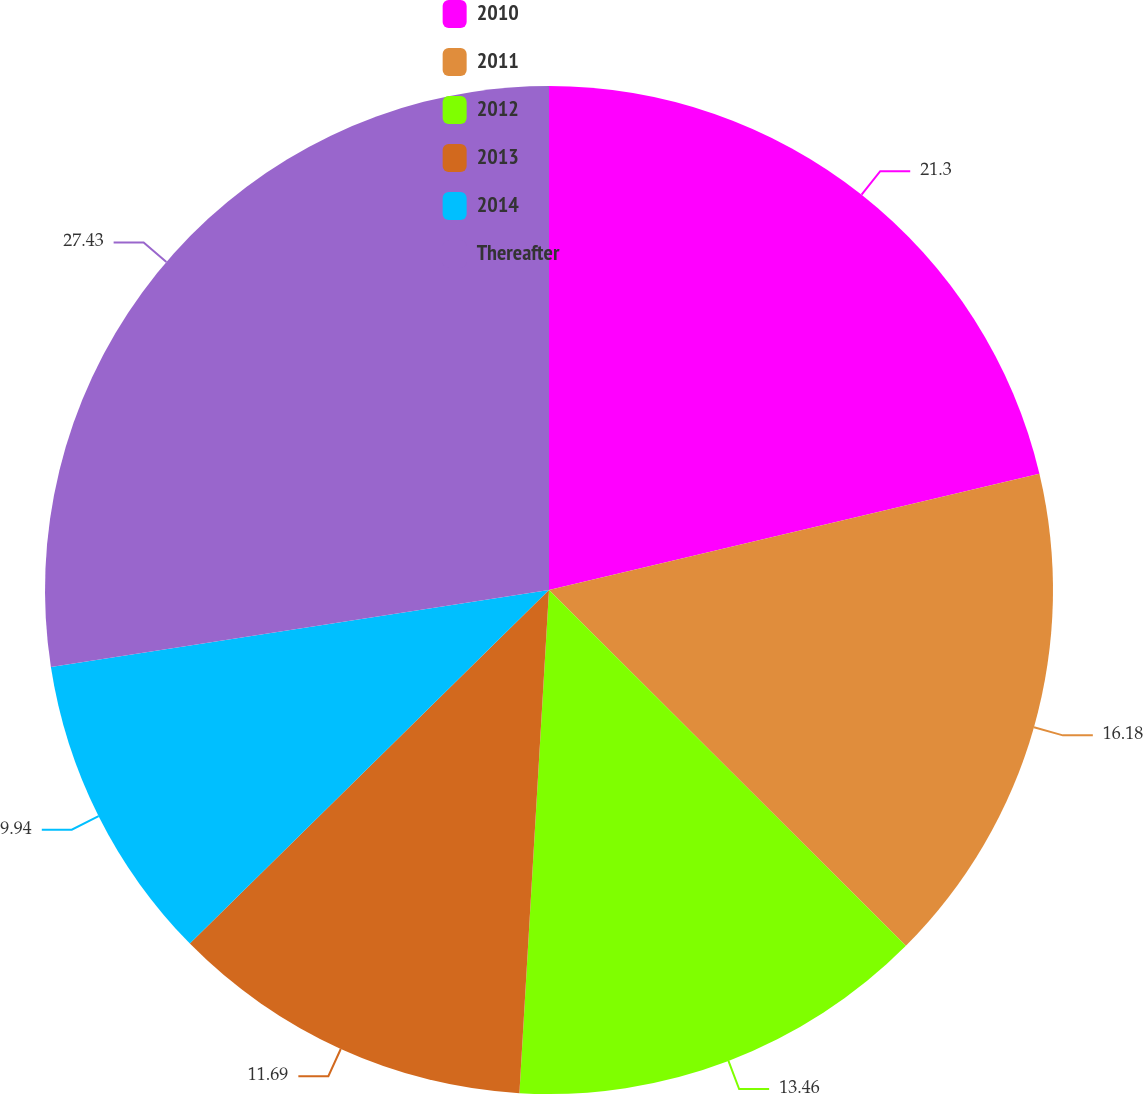Convert chart to OTSL. <chart><loc_0><loc_0><loc_500><loc_500><pie_chart><fcel>2010<fcel>2011<fcel>2012<fcel>2013<fcel>2014<fcel>Thereafter<nl><fcel>21.3%<fcel>16.18%<fcel>13.46%<fcel>11.69%<fcel>9.94%<fcel>27.44%<nl></chart> 